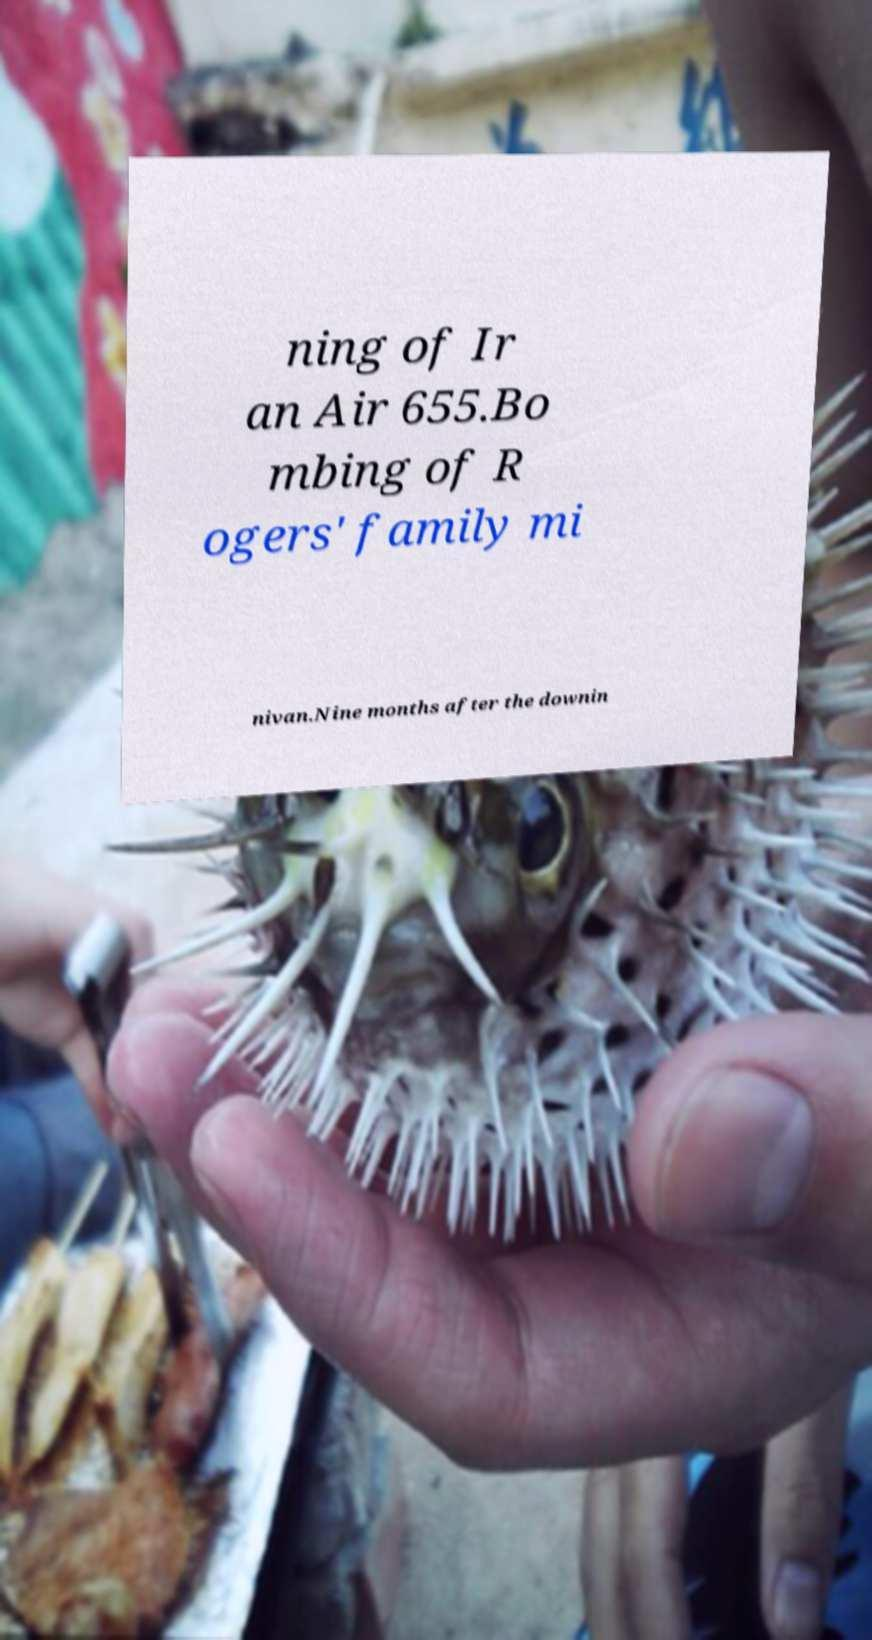Can you accurately transcribe the text from the provided image for me? ning of Ir an Air 655.Bo mbing of R ogers' family mi nivan.Nine months after the downin 